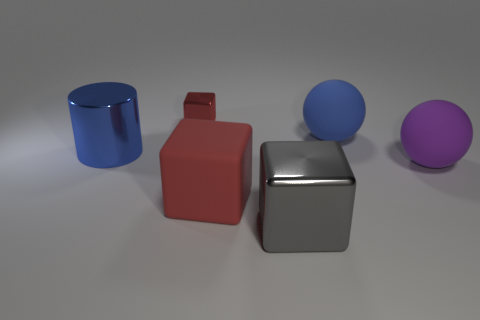How many things are either balls or large rubber objects that are behind the blue metal cylinder?
Give a very brief answer. 2. There is a red cube that is made of the same material as the big purple thing; what is its size?
Provide a succinct answer. Large. What is the shape of the large rubber thing right of the ball behind the big blue shiny object?
Give a very brief answer. Sphere. How big is the thing that is behind the purple matte sphere and on the right side of the large metal cube?
Provide a succinct answer. Large. Is there another matte thing that has the same shape as the large red matte thing?
Ensure brevity in your answer.  No. Are there any other things that are the same shape as the big blue rubber thing?
Provide a short and direct response. Yes. There is a big cube behind the metallic block that is in front of the red thing that is to the right of the small cube; what is its material?
Your response must be concise. Rubber. Is there a object that has the same size as the rubber block?
Give a very brief answer. Yes. The big shiny object that is left of the shiny block to the left of the large gray shiny block is what color?
Provide a short and direct response. Blue. How many big gray rubber blocks are there?
Provide a short and direct response. 0. 